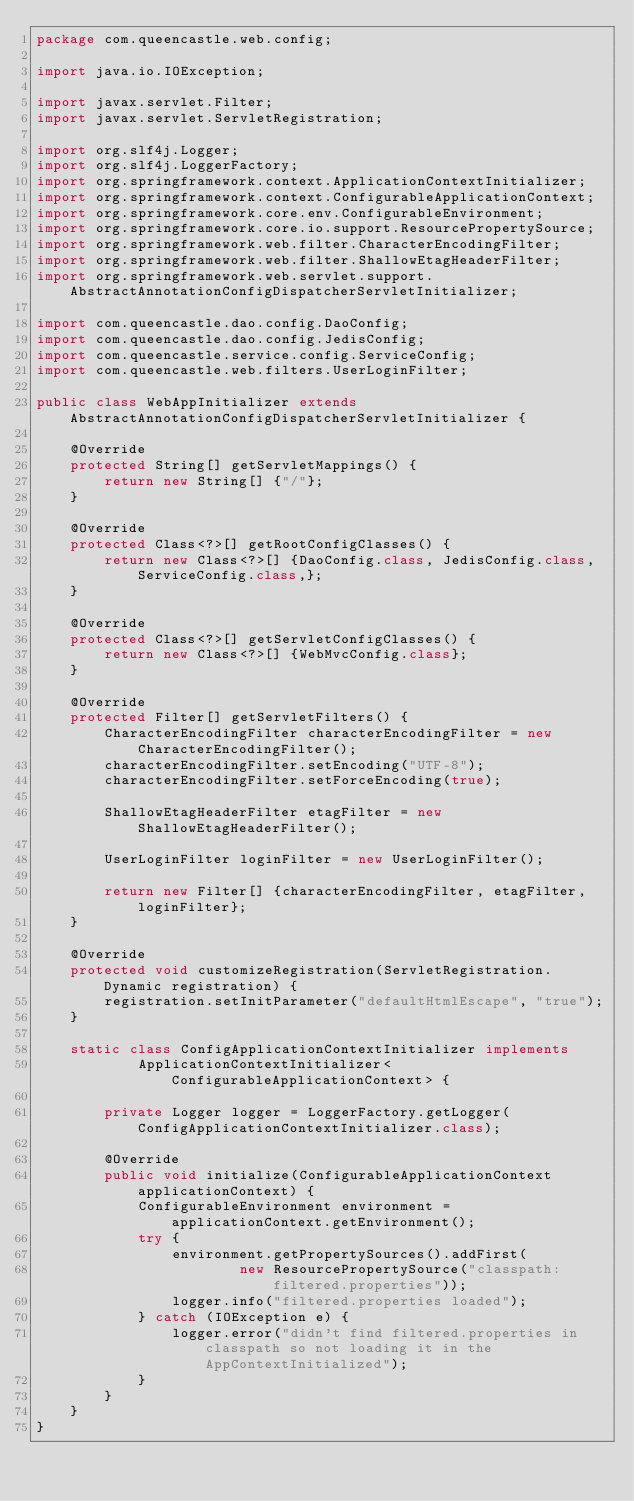Convert code to text. <code><loc_0><loc_0><loc_500><loc_500><_Java_>package com.queencastle.web.config;

import java.io.IOException;

import javax.servlet.Filter;
import javax.servlet.ServletRegistration;

import org.slf4j.Logger;
import org.slf4j.LoggerFactory;
import org.springframework.context.ApplicationContextInitializer;
import org.springframework.context.ConfigurableApplicationContext;
import org.springframework.core.env.ConfigurableEnvironment;
import org.springframework.core.io.support.ResourcePropertySource;
import org.springframework.web.filter.CharacterEncodingFilter;
import org.springframework.web.filter.ShallowEtagHeaderFilter;
import org.springframework.web.servlet.support.AbstractAnnotationConfigDispatcherServletInitializer;

import com.queencastle.dao.config.DaoConfig;
import com.queencastle.dao.config.JedisConfig;
import com.queencastle.service.config.ServiceConfig;
import com.queencastle.web.filters.UserLoginFilter;

public class WebAppInitializer extends AbstractAnnotationConfigDispatcherServletInitializer {

    @Override
    protected String[] getServletMappings() {
        return new String[] {"/"};
    }

    @Override
    protected Class<?>[] getRootConfigClasses() {
        return new Class<?>[] {DaoConfig.class, JedisConfig.class, ServiceConfig.class,};
    }

    @Override
    protected Class<?>[] getServletConfigClasses() {
        return new Class<?>[] {WebMvcConfig.class};
    }

    @Override
    protected Filter[] getServletFilters() {
        CharacterEncodingFilter characterEncodingFilter = new CharacterEncodingFilter();
        characterEncodingFilter.setEncoding("UTF-8");
        characterEncodingFilter.setForceEncoding(true);

        ShallowEtagHeaderFilter etagFilter = new ShallowEtagHeaderFilter();

        UserLoginFilter loginFilter = new UserLoginFilter();

        return new Filter[] {characterEncodingFilter, etagFilter, loginFilter};
    }

    @Override
    protected void customizeRegistration(ServletRegistration.Dynamic registration) {
        registration.setInitParameter("defaultHtmlEscape", "true");
    }

    static class ConfigApplicationContextInitializer implements
            ApplicationContextInitializer<ConfigurableApplicationContext> {

        private Logger logger = LoggerFactory.getLogger(ConfigApplicationContextInitializer.class);

        @Override
        public void initialize(ConfigurableApplicationContext applicationContext) {
            ConfigurableEnvironment environment = applicationContext.getEnvironment();
            try {
                environment.getPropertySources().addFirst(
                        new ResourcePropertySource("classpath:filtered.properties"));
                logger.info("filtered.properties loaded");
            } catch (IOException e) {
                logger.error("didn't find filtered.properties in classpath so not loading it in the AppContextInitialized");
            }
        }
    }
}
</code> 